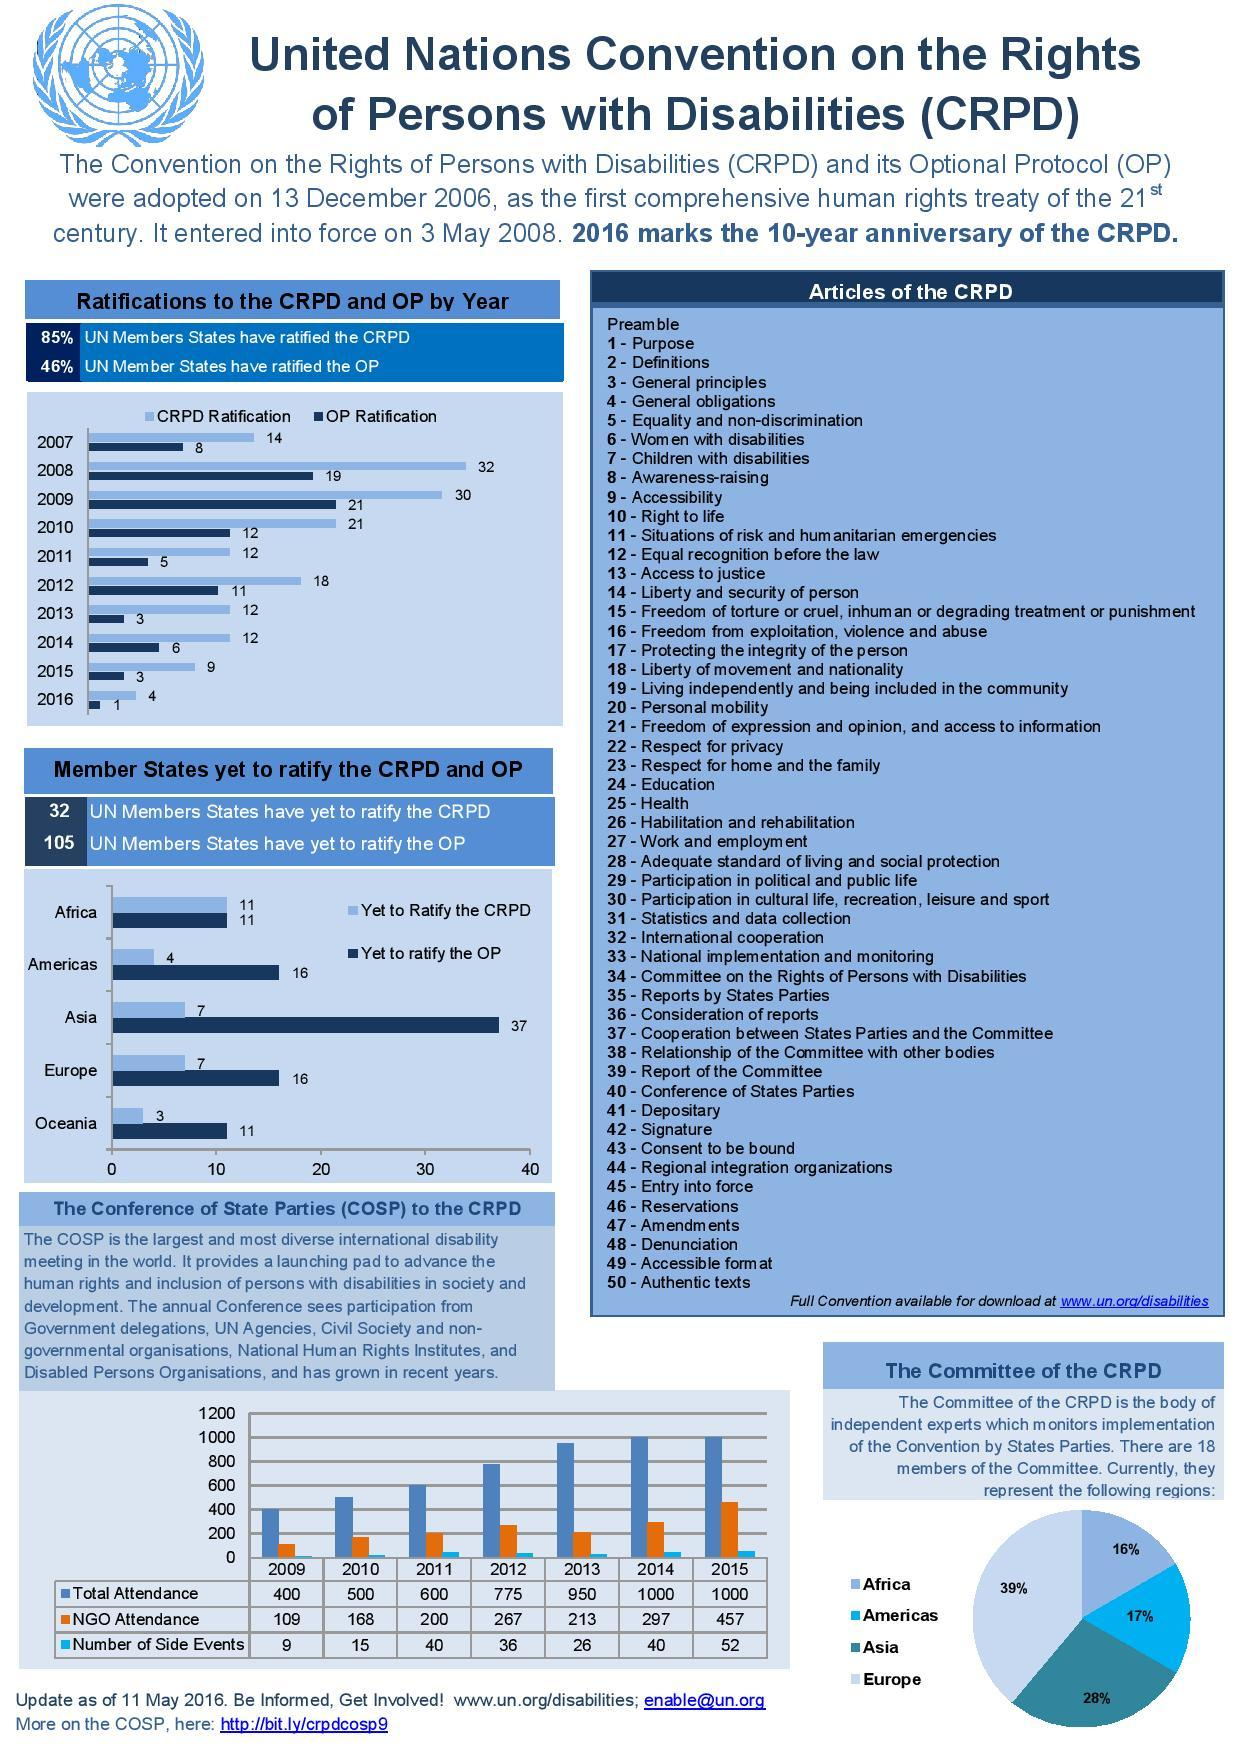Highlight a few significant elements in this photo. The second largest region in terms of leading at the Committee of the CPRD is Asia. There are currently 16 members of Europe that have not yet ratified the Convention on the Protection of the Rights of All Migrant Workers and Members of Their Families. In total, the CPRD has 51 articles, including the Preamble. There are currently 37 members in Asia who have not yet ratified the OP. In 2015, the attendance at NGO events was above 400. 